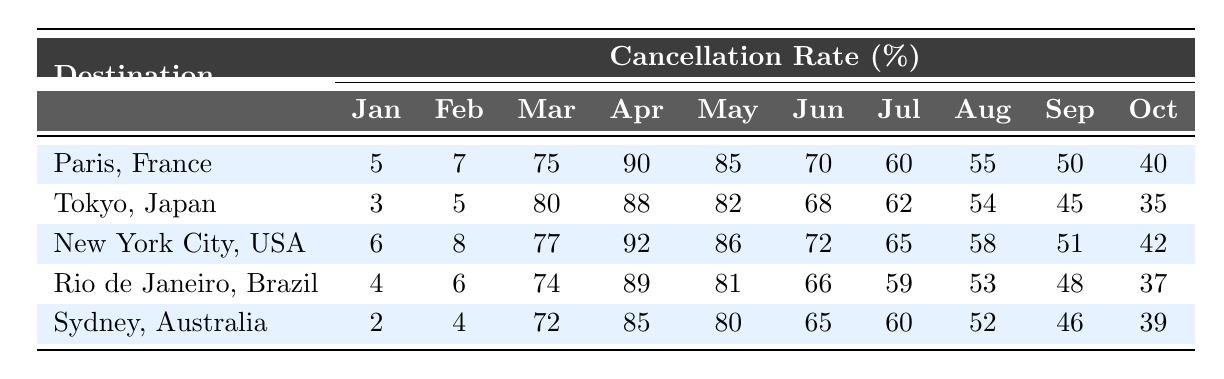What is the cancellation rate for Paris, France in April 2020? The table shows that the cancellation rate for Paris, France in April 2020 is listed under the April column for the destination Paris, which indicates a value of 90.
Answer: 90% Which destination had the highest cancellation rate in March 2020? Looking at the March 2020 column, the values for each destination are 75 (Paris), 80 (Tokyo), 77 (New York City), 74 (Rio de Janeiro), and 72 (Sydney). The highest value is 80 for Tokyo, indicating it had the highest cancellation rate.
Answer: Tokyo, Japan What was the average cancellation rate for Tokyo, Japan during the months of March, April, and May 2020? The cancellation rates for Tokyo in March, April, and May are 80, 88, and 82 respectively. To find the average, sum these values: 80 + 88 + 82 = 250. Dividing by 3, we get 250 / 3 = 83.33.
Answer: 83.33% Did the cancellation rate for New York City decrease or increase from May to June 2020? Looking at the rates for New York City, the cancellation rate for May is 86 and for June it is 72. Since 72 is lower than 86, it indicates a decrease in the cancellation rate from May to June.
Answer: Decrease Which month had the lowest cancellation rate for Rio de Janeiro, Brazil? The cancellation rates for Rio de Janeiro across the months are: January: 4, February: 6, March: 74, April: 89, May: 81, June: 66, July: 59, August: 53, September: 48, and October: 37. The lowest value is 4 for January.
Answer: January 2020 What is the difference in cancellation rates between April and October for Sydney, Australia? For Sydney in April 2020 the cancellation rate is 85, and in October 2020 it is 39. The difference is calculated as 85 - 39 = 46.
Answer: 46% Which destination had a cancellation rate of 40% in October 2020? In the table, the cancellation rates for October 2020 are listed as follows: Paris (40), Tokyo (35), New York City (42), Rio de Janeiro (37), and Sydney (39). Paris is the only destination with a rate of 40%.
Answer: Paris, France What was the trend of cancellation rates for Europe from March to October 2020? For Paris, the cancellation rates from March to October in 2020 are 75, 90, 85, 70, 60, 55, 50, and 40, showing a clear trend of declining rates from a peak in April down to 40 in October.
Answer: Declining 